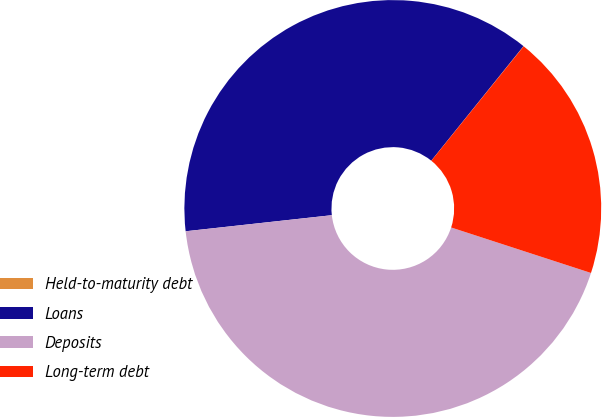Convert chart. <chart><loc_0><loc_0><loc_500><loc_500><pie_chart><fcel>Held-to-maturity debt<fcel>Loans<fcel>Deposits<fcel>Long-term debt<nl><fcel>0.02%<fcel>37.53%<fcel>43.25%<fcel>19.2%<nl></chart> 